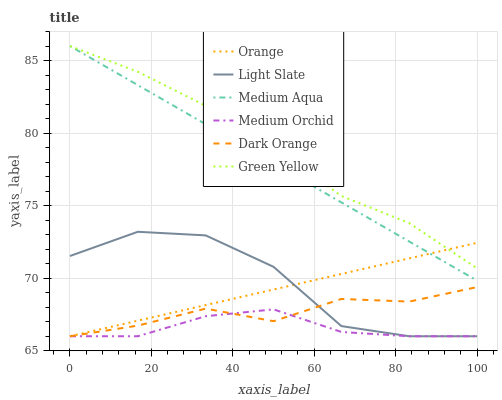Does Medium Orchid have the minimum area under the curve?
Answer yes or no. Yes. Does Green Yellow have the maximum area under the curve?
Answer yes or no. Yes. Does Light Slate have the minimum area under the curve?
Answer yes or no. No. Does Light Slate have the maximum area under the curve?
Answer yes or no. No. Is Medium Aqua the smoothest?
Answer yes or no. Yes. Is Light Slate the roughest?
Answer yes or no. Yes. Is Medium Orchid the smoothest?
Answer yes or no. No. Is Medium Orchid the roughest?
Answer yes or no. No. Does Dark Orange have the lowest value?
Answer yes or no. Yes. Does Medium Aqua have the lowest value?
Answer yes or no. No. Does Green Yellow have the highest value?
Answer yes or no. Yes. Does Light Slate have the highest value?
Answer yes or no. No. Is Light Slate less than Green Yellow?
Answer yes or no. Yes. Is Green Yellow greater than Dark Orange?
Answer yes or no. Yes. Does Dark Orange intersect Medium Orchid?
Answer yes or no. Yes. Is Dark Orange less than Medium Orchid?
Answer yes or no. No. Is Dark Orange greater than Medium Orchid?
Answer yes or no. No. Does Light Slate intersect Green Yellow?
Answer yes or no. No. 